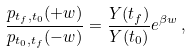<formula> <loc_0><loc_0><loc_500><loc_500>\frac { p _ { t _ { f } , t _ { 0 } } ( + w ) } { p _ { t _ { 0 } , t _ { f } } ( - w ) } = \frac { Y ( t _ { f } ) } { Y ( t _ { 0 } ) } e ^ { \beta w } \, ,</formula> 